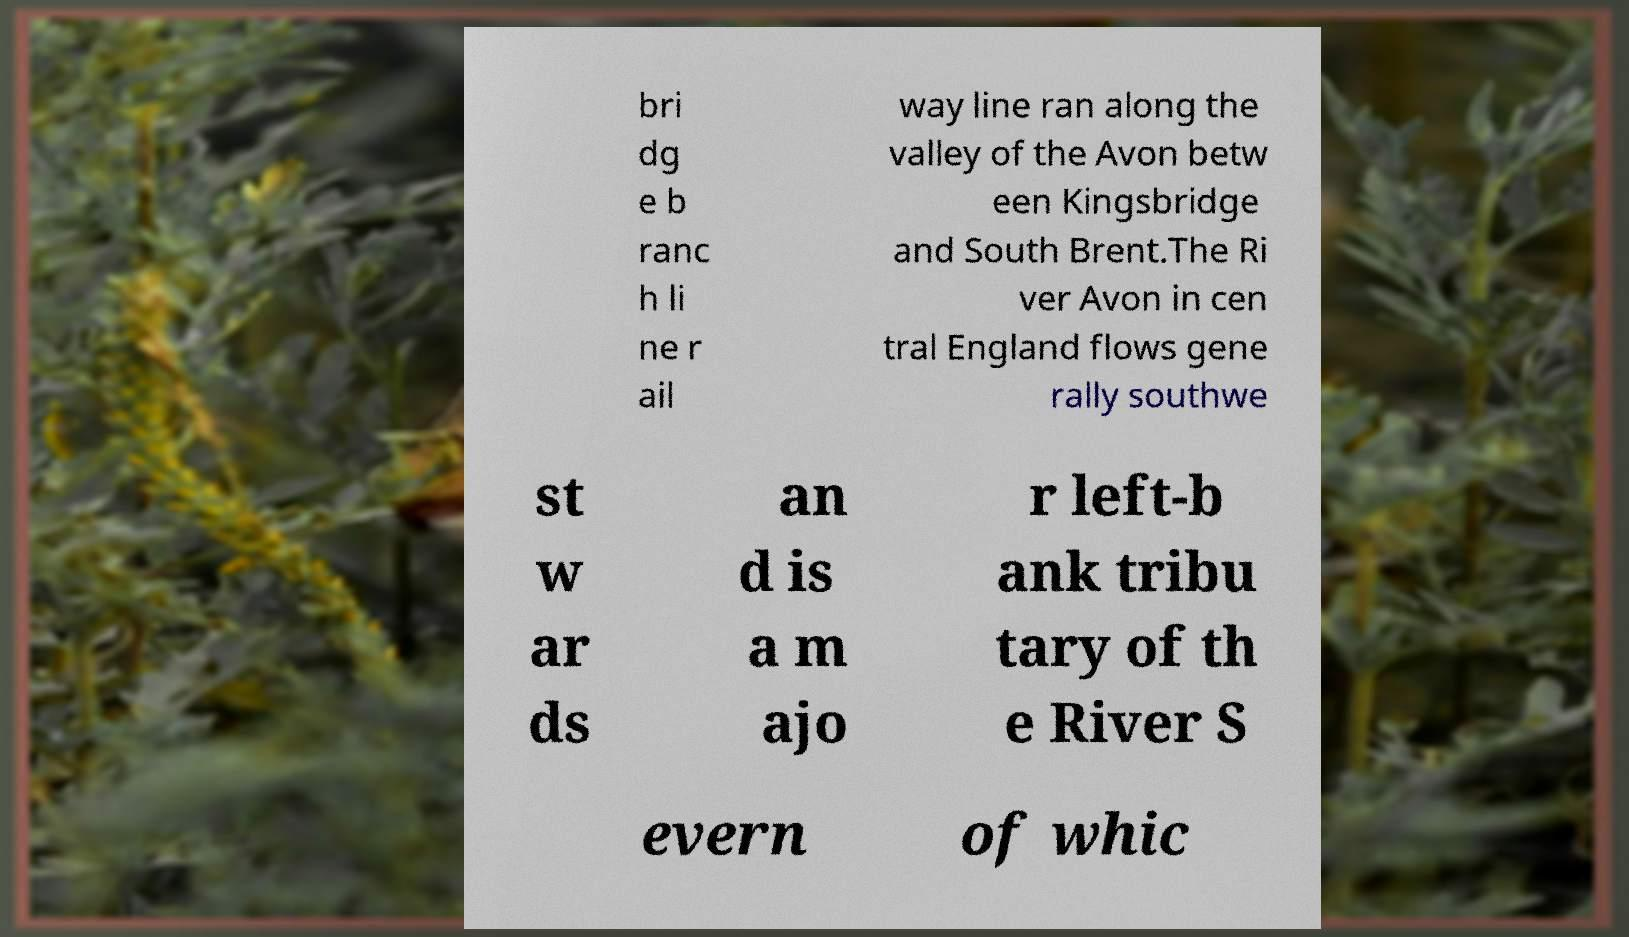What messages or text are displayed in this image? I need them in a readable, typed format. bri dg e b ranc h li ne r ail way line ran along the valley of the Avon betw een Kingsbridge and South Brent.The Ri ver Avon in cen tral England flows gene rally southwe st w ar ds an d is a m ajo r left-b ank tribu tary of th e River S evern of whic 